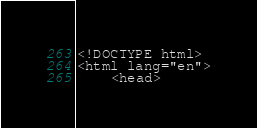Convert code to text. <code><loc_0><loc_0><loc_500><loc_500><_PHP_><!DOCTYPE html>
<html lang="en">
	<head></code> 